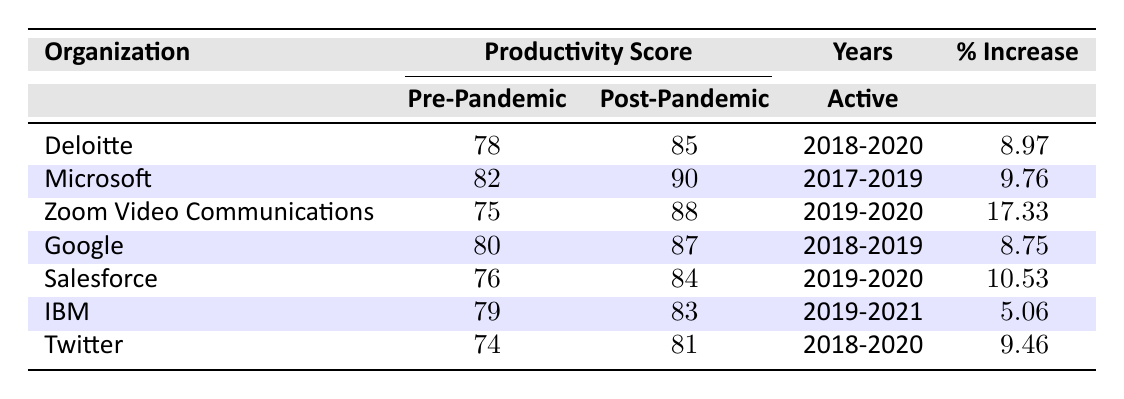What is the post-pandemic productivity score for Microsoft? The table lists the productivity scores for each organization. Looking at Microsoft, the post-pandemic productivity score is provided directly in the corresponding column.
Answer: 90 Which organization had the highest percentage increase in productivity score? By comparing the percentage increases, we can see that Zoom Video Communications has the highest percentage increase of 17.33.
Answer: Zoom Video Communications What is the average pre-pandemic productivity score among all organizations? To find the average, sum the pre-pandemic scores: 78 + 82 + 75 + 80 + 76 + 79 + 74 = 524. There are 7 organizations, so the average is 524/7 = 74.86.
Answer: 74.86 Did any organization have a post-pandemic productivity score below 80? Looking through the post-pandemic scores in the table, both Twitter (81) and IBM (83) have scores below 85, but all listed organizations are 80 or higher. Thus, the answer is no.
Answer: No What is the difference in productivity score for IBM between pre-pandemic and post-pandemic? The pre-pandemic score for IBM is 79, and the post-pandemic score is 83. To find the difference, subtract the pre-pandemic score from the post-pandemic score: 83 - 79 = 4.
Answer: 4 Which organizations had a pre-pandemic productivity score above 80? By observing the pre-pandemic scores, we see that Microsoft (82), and Google (80) are above 80. Therefore, the relevant organizations are Microsoft.
Answer: Microsoft How many organizations exhibited a percentage increase of more than 10%? From the percentage increase column, we filter the values above 10% and find Salesforce (10.53) and Zoom Video Communications (17.33). Hence, there are 2 organizations.
Answer: 2 What percentage increase did Deloitte experience? Deloitte's percentage increase is explicitly listed in the table. The value is directly stated as 8.97%.
Answer: 8.97% 